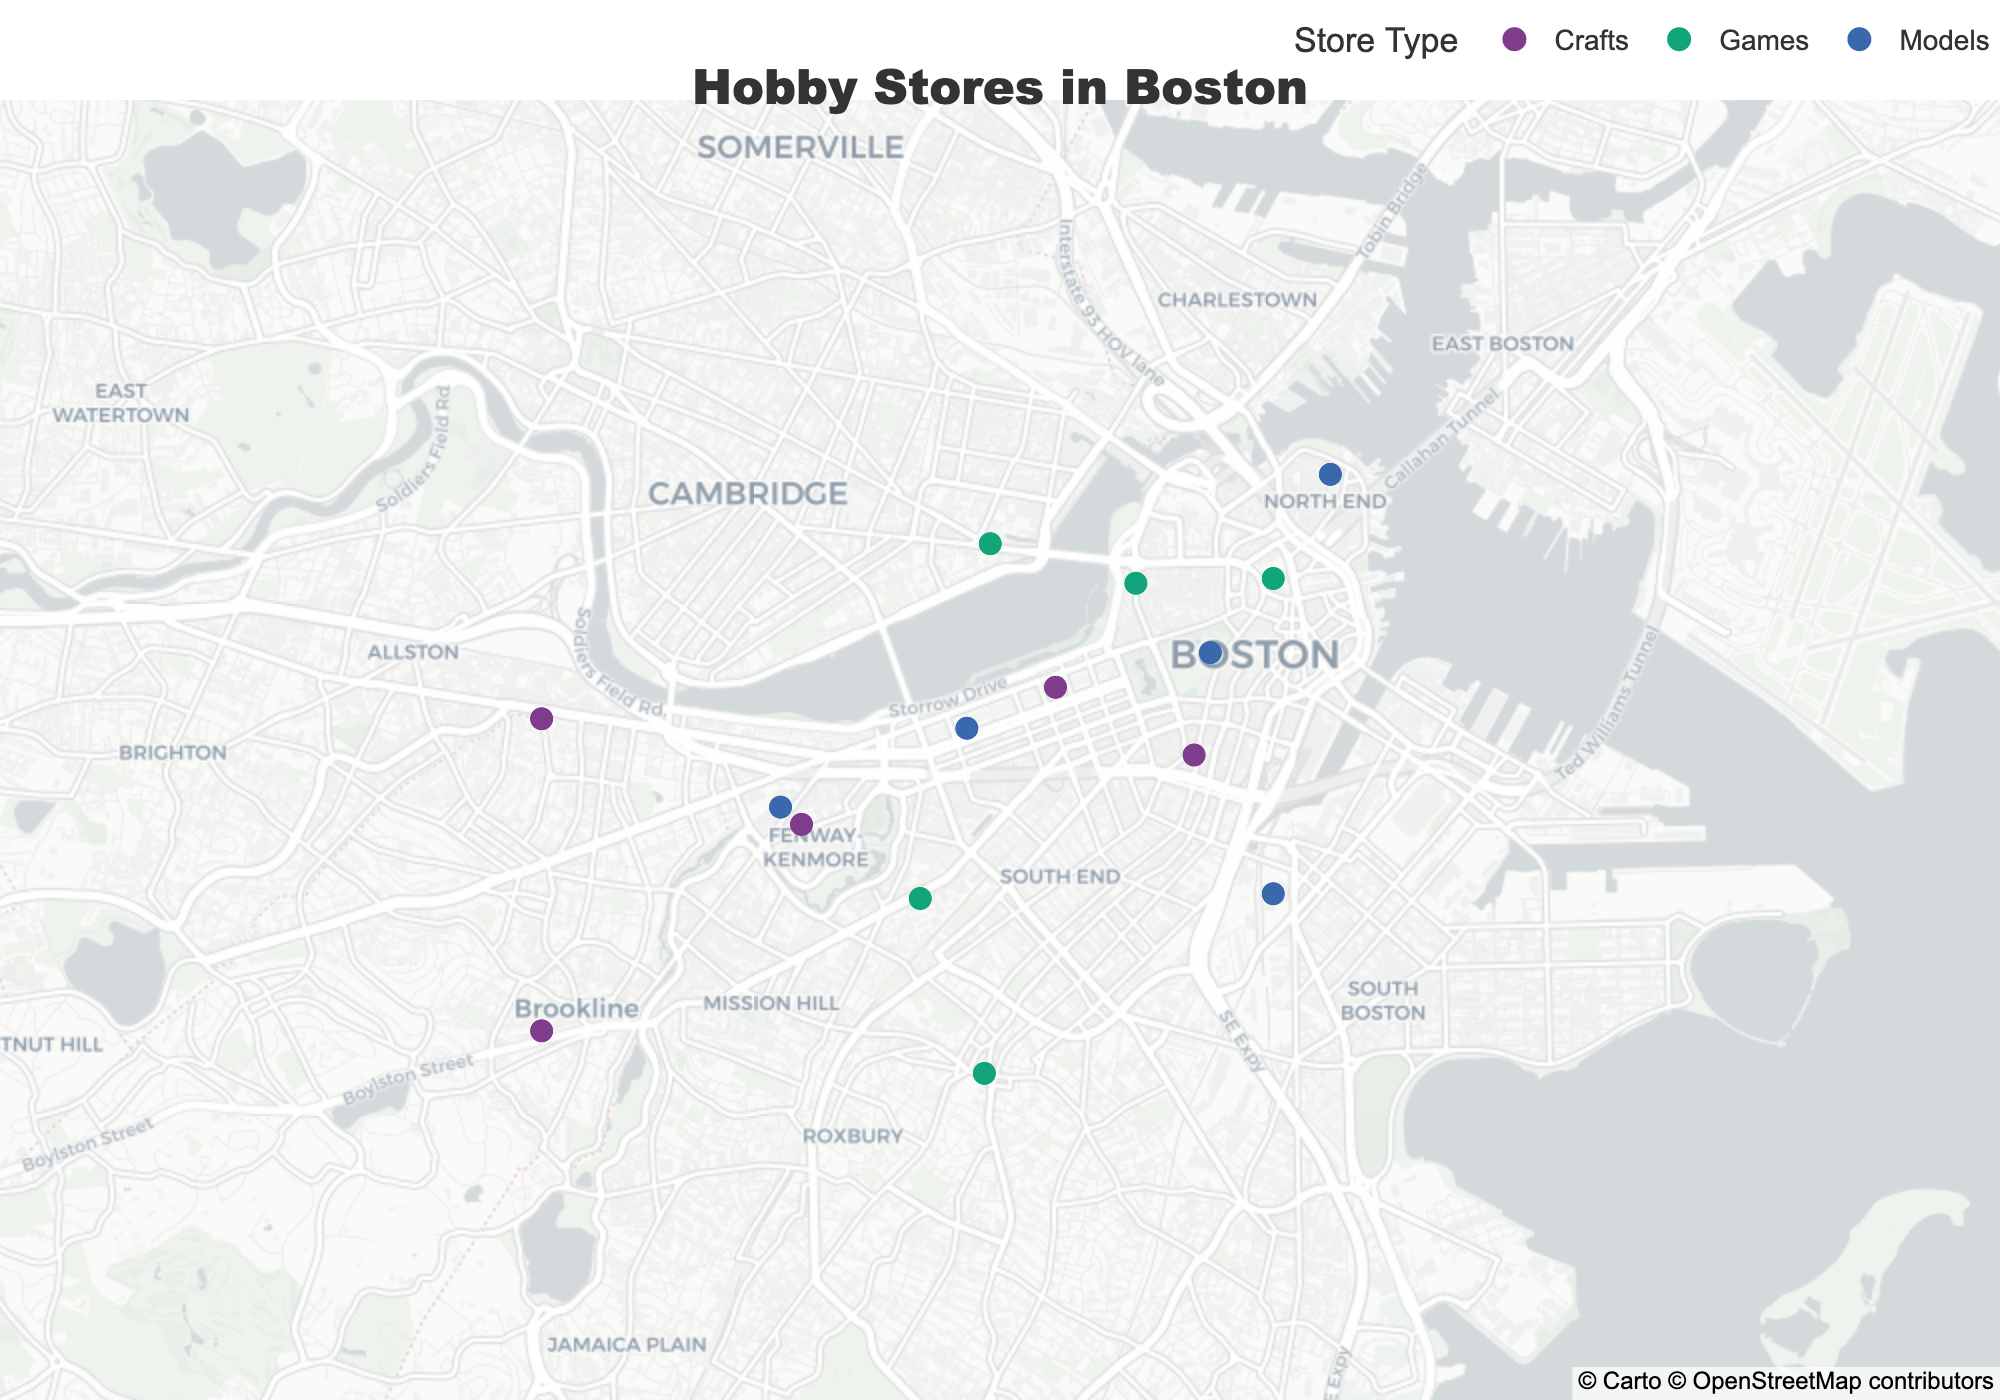What's the title of the map? The title of the map is located at the top center and is displayed in bold font. The map title is "Hobby Stores in Boston"
Answer: Hobby Stores in Boston How many hobby stores are there? Count the total number of data points (markers) on the map. By counting each marker representing a hobby store, there are 15 stores in total.
Answer: 15 Which type of hobby store has the most locations? Compare the number of data points (markers) for each store type by counting the colors representing "Crafts," "Games," and "Models." "Games" has the most with 5 stores.
Answer: Games Which store is located farthest to the east? Identify the store with the highest longitude value. On the map, "Scale Model Haven" is located at the longitude 71.0540, which is the easternmost location.
Answer: Scale Model Haven How many craft stores are there west of 71.08 longitude? Identify the markers representing "Crafts," then count those whose longitude value is greater than 71.08. There are 4 craft stores located west of 71.08 longitude.
Answer: 4 Which hobby store is closest to the center of the map? Assess the proximity of each marker to the map's central coordinates. "Harbor Games," located at latitude 42.3601 and longitude 71.0589, is closest to the map center.
Answer: Harbor Games What is the average latitude of the model stores? Sum the latitude values of all model stores (42.3506 + 42.3554 + 42.3667 + 42.3401 + 42.3456) and divide by the number of model stores (5). The sum is 210.7583 and the average is 210.7583/5 = 42.1517.
Answer: 42.1517 Are the craft stores more spread out than the game stores? Compare the geographic dispersion (range of latitude and longitude) of craft stores and game stores. Craft stores are dispersed between latitudes 42.3287 and 42.3532 and longitudes 71.0589 and 71.1217, while game stores are between latitudes 42.3287 and 42.3623 and longitudes 71.0589 and 71.0892. Crafts stores are more spread out.
Answer: Yes Which types of stores tend to cluster together? Visually inspect the map for clusters of markers with the same color. "Crafts" stores show a closer clustering with multiple stores appearing in proximity to each other in the west-central part of the map.
Answer: Crafts How many hobby stores are north of 42.35 latitude? Identify the hobby stores with latitude values greater than 42.35 and count them. There are 6 stores located north of 42.35 latitude.
Answer: 6 